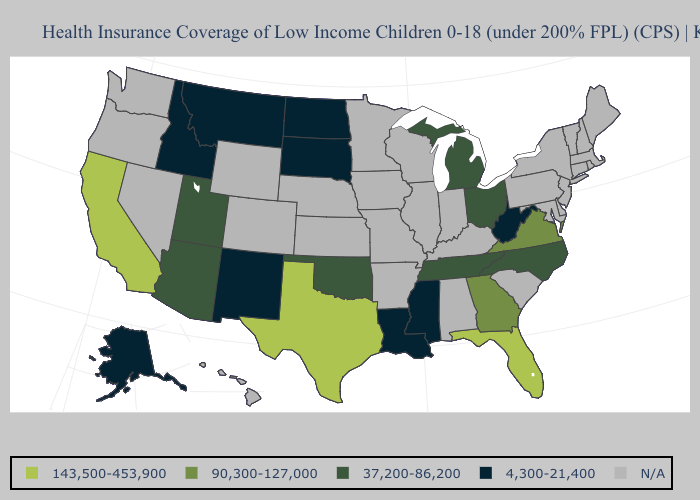What is the highest value in the USA?
Be succinct. 143,500-453,900. What is the value of Mississippi?
Concise answer only. 4,300-21,400. What is the value of Louisiana?
Answer briefly. 4,300-21,400. What is the value of Connecticut?
Keep it brief. N/A. Which states have the lowest value in the USA?
Give a very brief answer. Alaska, Idaho, Louisiana, Mississippi, Montana, New Mexico, North Dakota, South Dakota, West Virginia. Is the legend a continuous bar?
Concise answer only. No. What is the value of South Dakota?
Write a very short answer. 4,300-21,400. What is the value of North Dakota?
Be succinct. 4,300-21,400. What is the lowest value in the South?
Concise answer only. 4,300-21,400. 